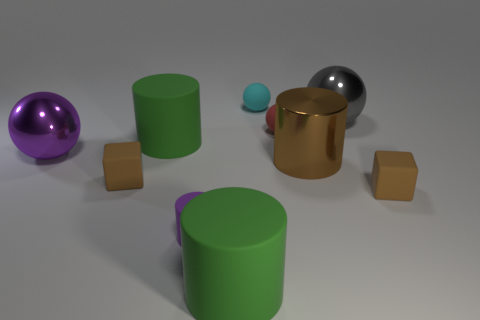Is the gray thing the same size as the purple rubber object?
Offer a very short reply. No. Is the material of the big gray object the same as the large green thing in front of the tiny purple cylinder?
Your answer should be very brief. No. There is a metallic thing on the left side of the purple matte cylinder; is its color the same as the small cylinder?
Your answer should be very brief. Yes. What number of large shiny spheres are in front of the big gray metallic ball and to the right of the brown metallic object?
Offer a very short reply. 0. How many other objects are the same material as the small purple thing?
Offer a terse response. 6. Are the large green cylinder on the left side of the small cylinder and the big brown cylinder made of the same material?
Offer a terse response. No. There is a purple object that is right of the big green rubber thing that is on the left side of the green thing in front of the small cylinder; what is its size?
Your answer should be very brief. Small. What number of other things are the same color as the tiny cylinder?
Your answer should be compact. 1. What is the shape of the purple rubber thing that is the same size as the red thing?
Provide a short and direct response. Cylinder. There is a rubber ball in front of the gray thing; what size is it?
Offer a terse response. Small. 